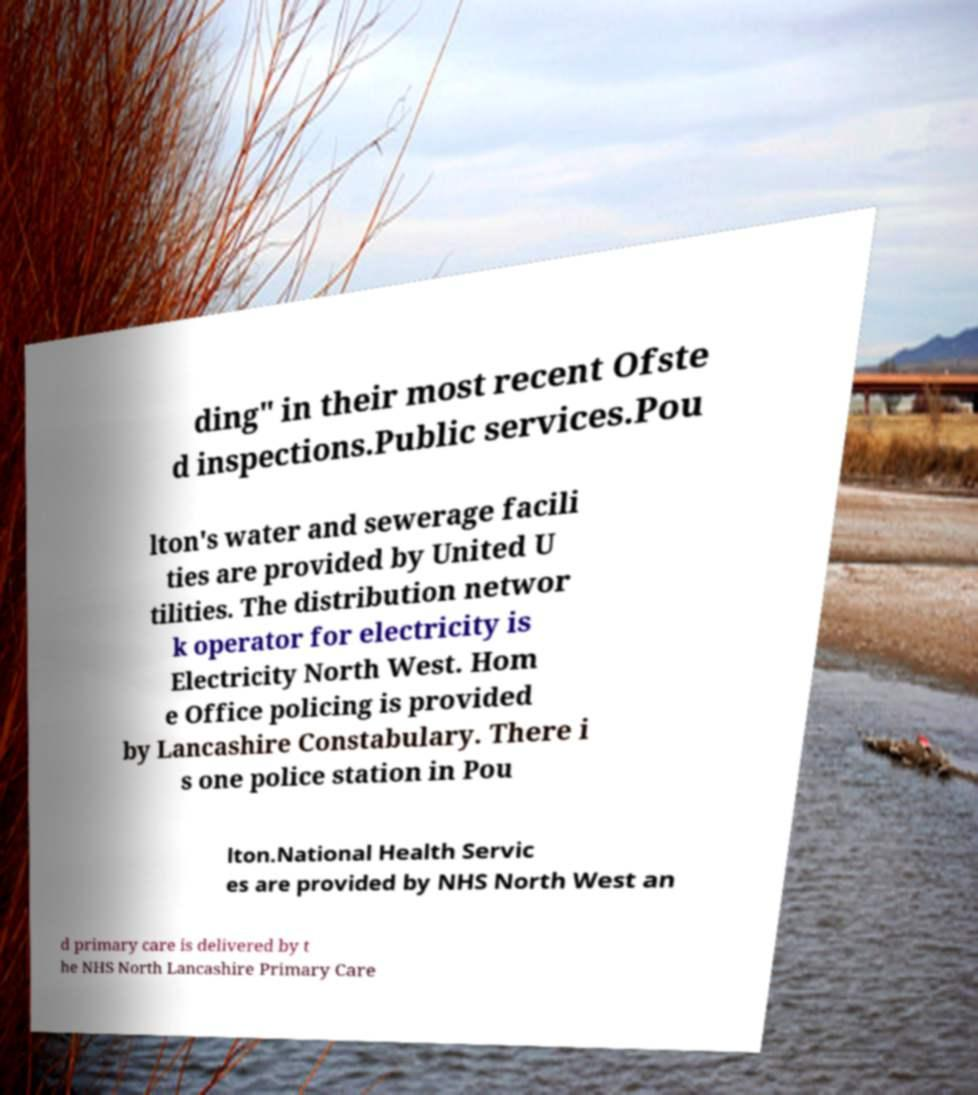There's text embedded in this image that I need extracted. Can you transcribe it verbatim? ding" in their most recent Ofste d inspections.Public services.Pou lton's water and sewerage facili ties are provided by United U tilities. The distribution networ k operator for electricity is Electricity North West. Hom e Office policing is provided by Lancashire Constabulary. There i s one police station in Pou lton.National Health Servic es are provided by NHS North West an d primary care is delivered by t he NHS North Lancashire Primary Care 